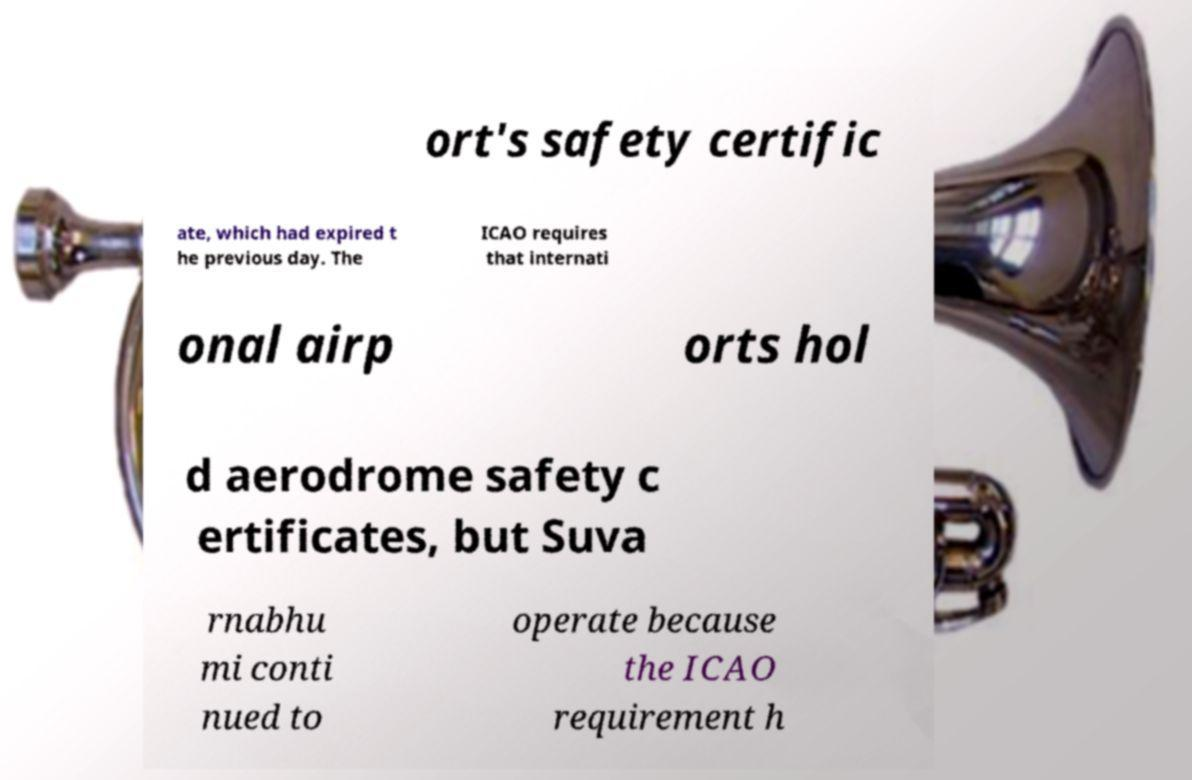Please identify and transcribe the text found in this image. ort's safety certific ate, which had expired t he previous day. The ICAO requires that internati onal airp orts hol d aerodrome safety c ertificates, but Suva rnabhu mi conti nued to operate because the ICAO requirement h 